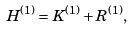<formula> <loc_0><loc_0><loc_500><loc_500>H ^ { ( 1 ) } = K ^ { ( 1 ) } + R ^ { ( 1 ) } ,</formula> 